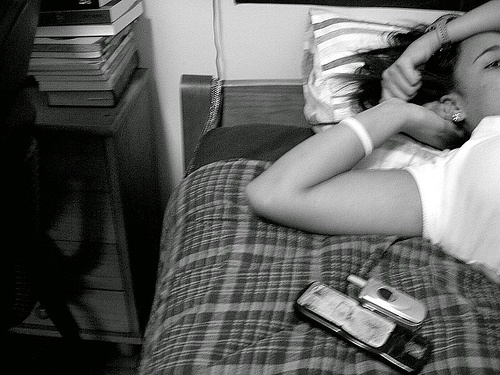Describe the objects in this image and their specific colors. I can see bed in black, gray, darkgray, and lightgray tones, people in black, darkgray, gainsboro, and gray tones, remote in black, darkgray, lightgray, and gray tones, cell phone in black, darkgray, lightgray, and gray tones, and book in black and gray tones in this image. 